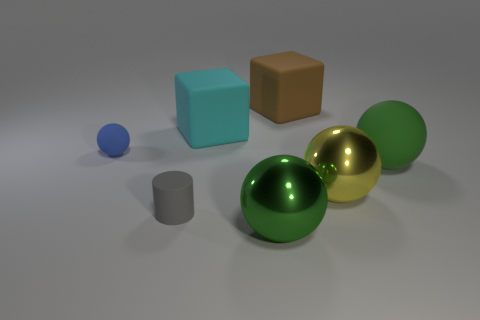Subtract 2 balls. How many balls are left? 2 Add 2 large blue matte balls. How many objects exist? 9 Subtract all yellow balls. How many balls are left? 3 Subtract all blue matte balls. How many balls are left? 3 Subtract all cyan spheres. Subtract all blue cylinders. How many spheres are left? 4 Subtract all blocks. How many objects are left? 5 Subtract all green objects. Subtract all big metallic things. How many objects are left? 3 Add 7 gray rubber objects. How many gray rubber objects are left? 8 Add 1 gray balls. How many gray balls exist? 1 Subtract 0 red spheres. How many objects are left? 7 